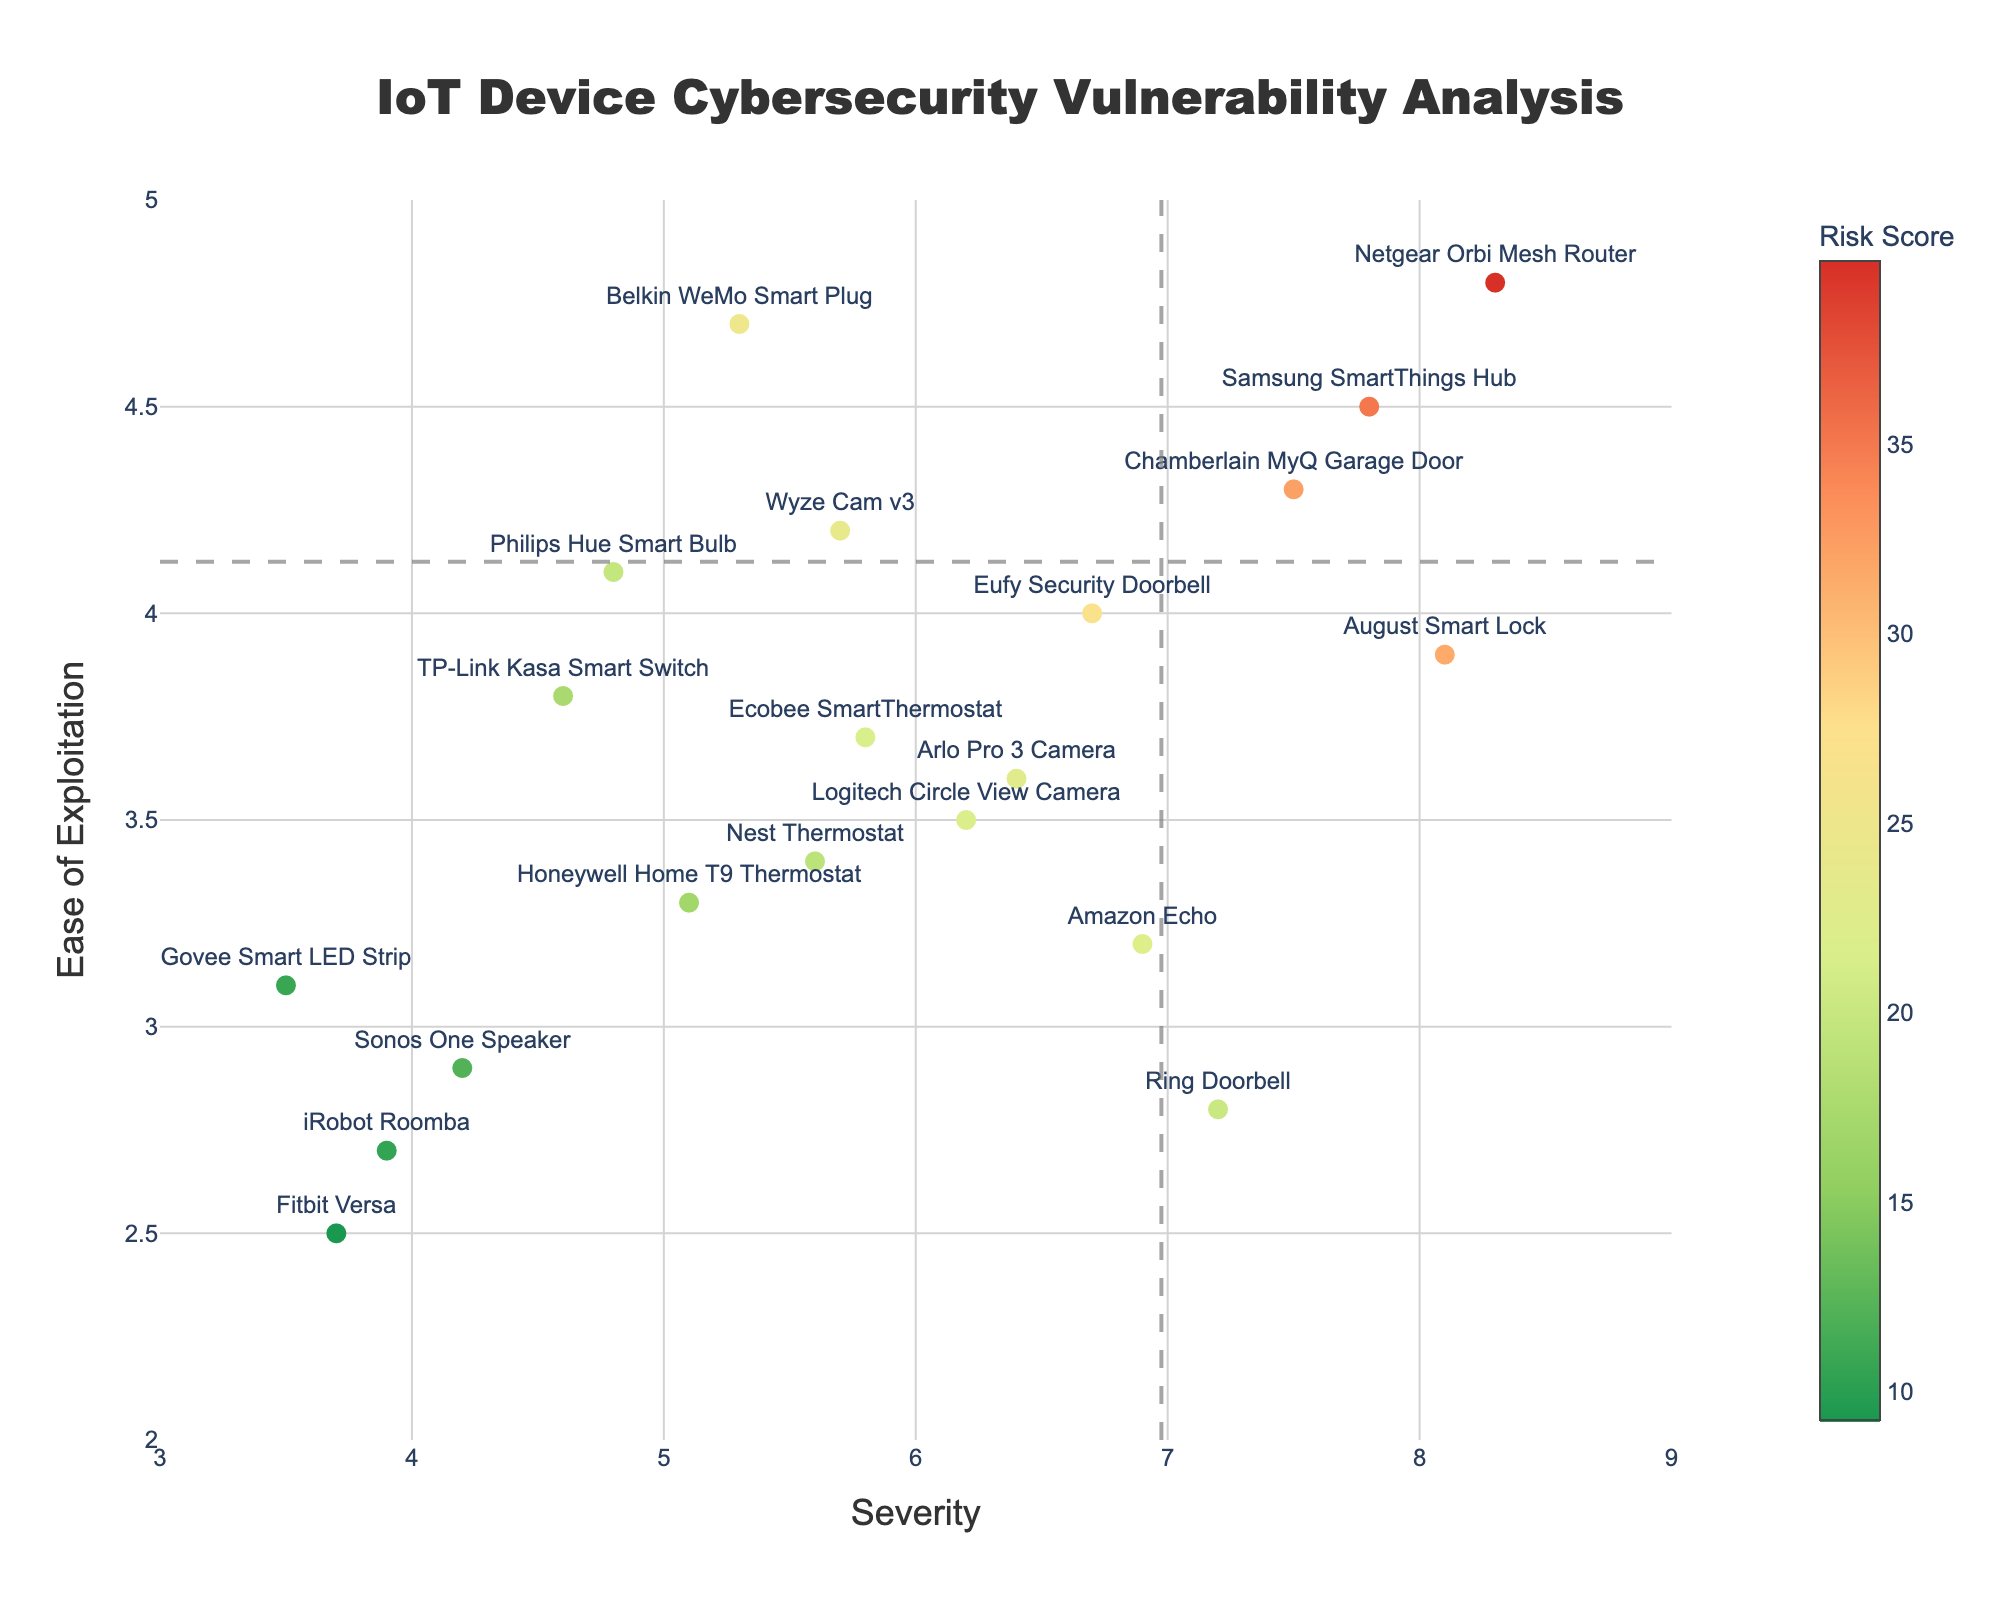What is the title of the plot? The title of the plot is displayed at the top.
Answer: IoT Device Cybersecurity Vulnerability Analysis How many devices are represented in the plot? Count the total number of devices listed on the axes.
Answer: 20 Which device has the highest severity score? Find the device that has the highest value on the x-axis (severity).
Answer: Netgear Orbi Mesh Router Which device is the easiest to exploit? Find the device that has the highest value on the y-axis (Ease of Exploitation).
Answer: Netgear Orbi Mesh Router What is the color range used for the risk score in the plot? Look at the colorbar to determine the color range.
Answer: Shades from green to red Which device has the highest risk score? The highest risk score correlates with the highest product of severity and ease of exploitation.
Answer: Netgear Orbi Mesh Router How do the thresholds for severity and ease of exploitation divide the plot? Identify how the threshold lines split the plot into quadrants.
Answer: Into four quadrants: high and low severity crossed with high and low ease of exploitation Between the Ring Doorbell and the August Smart Lock, which device has a higher risk score? Compare the product of severity and ease of exploitation for both devices. August Smart Lock has scores 8.1 and 3.9 (31.59), and the Ring Doorbell has scores 7.2 and 2.8 (20.16).
Answer: August Smart Lock How many devices are above both the severity and ease of exploitation thresholds? Count the number of data points in the top-right quadrant.
Answer: 3 Which device is the safest based on the plot? Identify the device with the lowest combination of severity and ease of exploitation scores.
Answer: Govee Smart LED Strip 